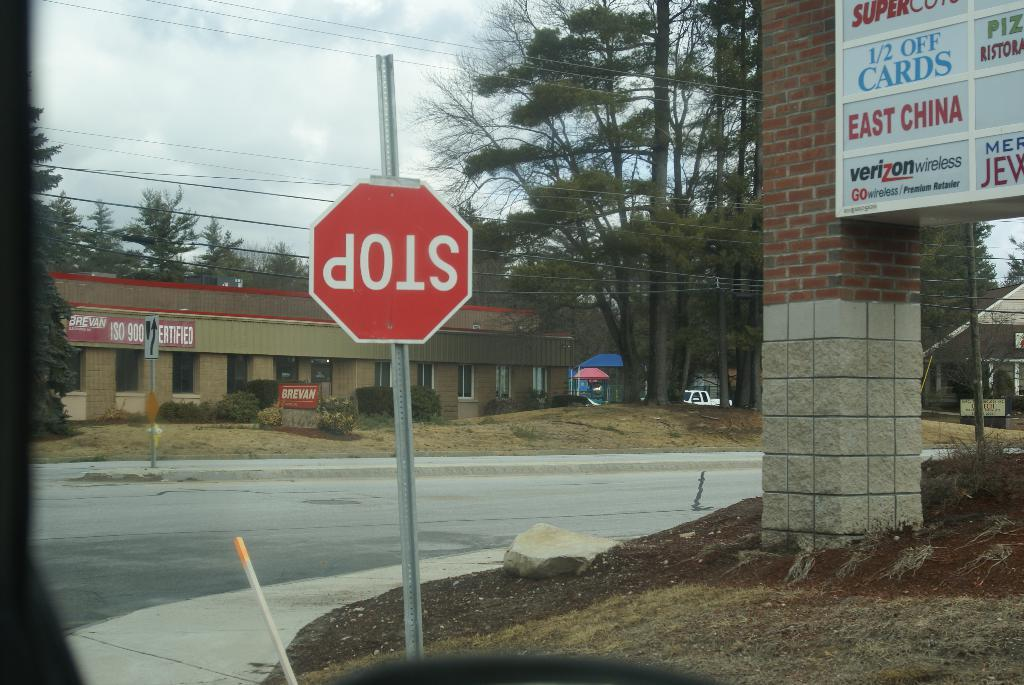Provide a one-sentence caption for the provided image. A street corner next to a mini mall contains a stop sign that is upside down. 